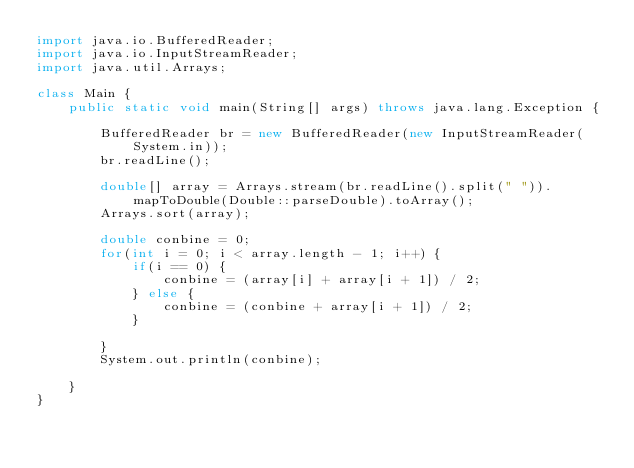<code> <loc_0><loc_0><loc_500><loc_500><_Java_>import java.io.BufferedReader;
import java.io.InputStreamReader;
import java.util.Arrays;

class Main {
    public static void main(String[] args) throws java.lang.Exception {

        BufferedReader br = new BufferedReader(new InputStreamReader(System.in));
        br.readLine();

        double[] array = Arrays.stream(br.readLine().split(" ")).mapToDouble(Double::parseDouble).toArray();
        Arrays.sort(array);

        double conbine = 0;
        for(int i = 0; i < array.length - 1; i++) {
            if(i == 0) {
                conbine = (array[i] + array[i + 1]) / 2;
            } else {
                conbine = (conbine + array[i + 1]) / 2;
            }

        }
        System.out.println(conbine);

    }
}</code> 